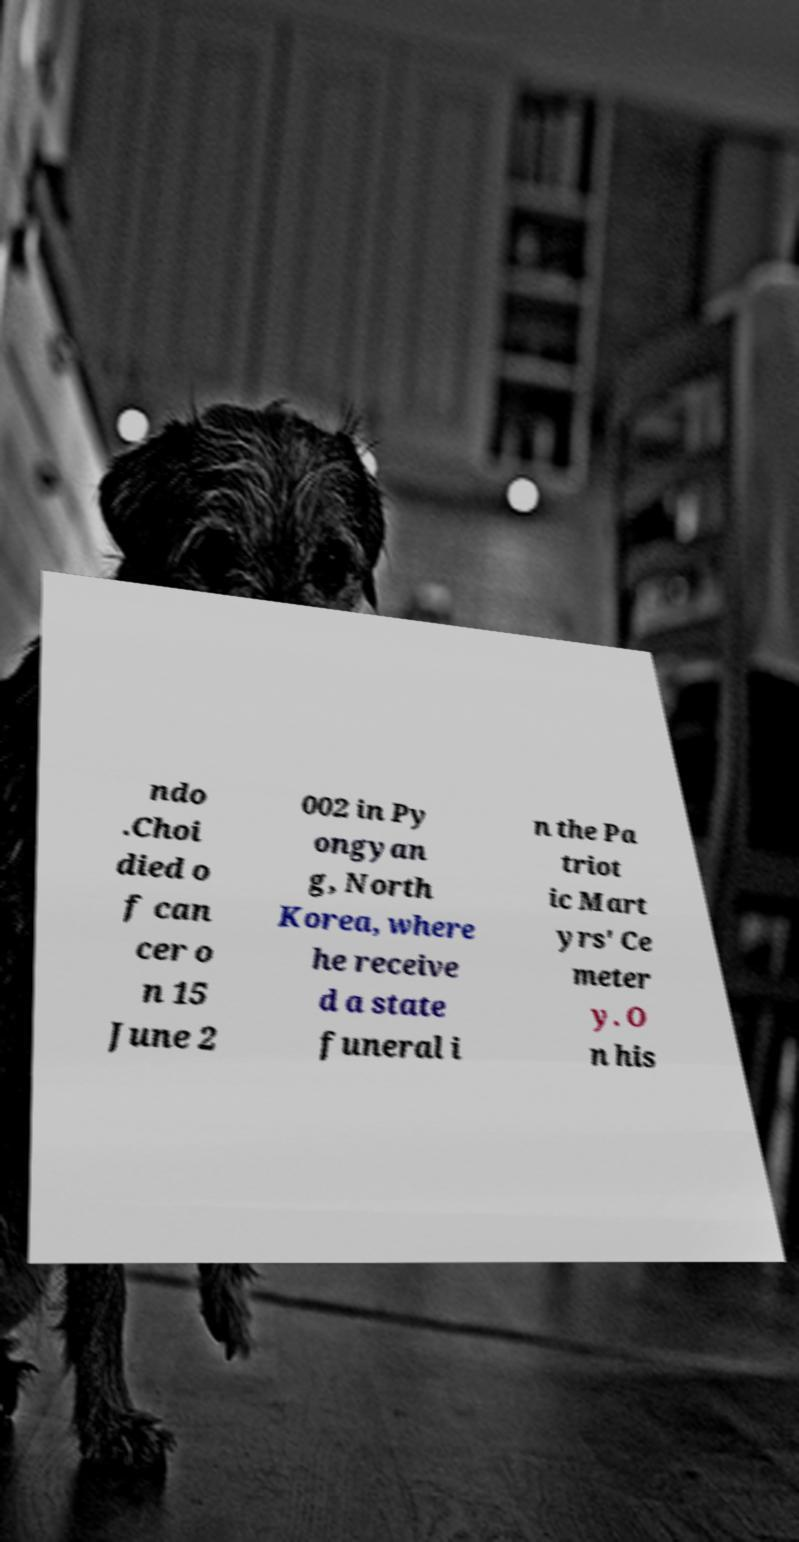Could you extract and type out the text from this image? ndo .Choi died o f can cer o n 15 June 2 002 in Py ongyan g, North Korea, where he receive d a state funeral i n the Pa triot ic Mart yrs' Ce meter y. O n his 